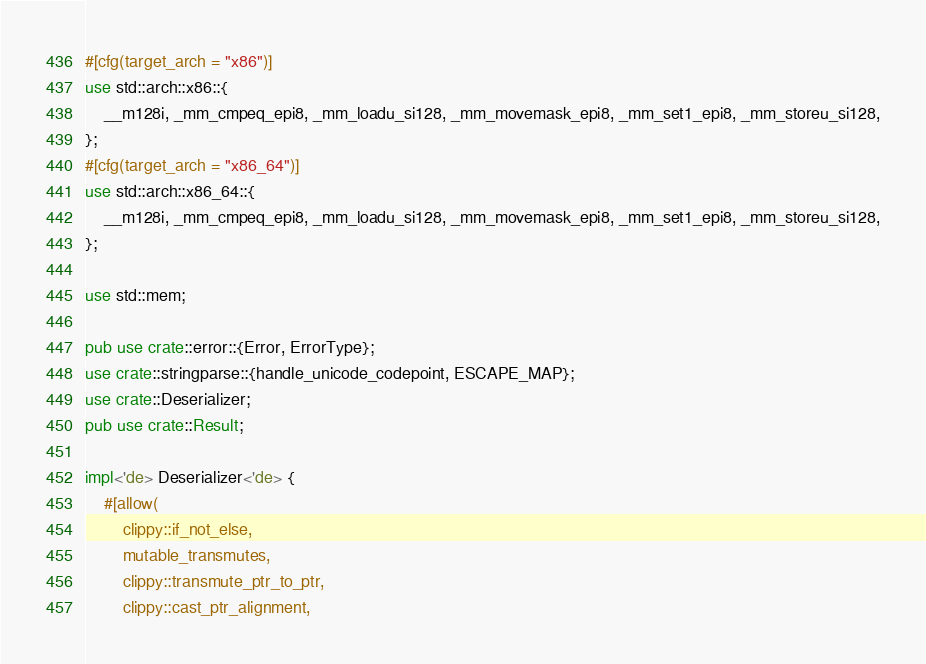<code> <loc_0><loc_0><loc_500><loc_500><_Rust_>#[cfg(target_arch = "x86")]
use std::arch::x86::{
    __m128i, _mm_cmpeq_epi8, _mm_loadu_si128, _mm_movemask_epi8, _mm_set1_epi8, _mm_storeu_si128,
};
#[cfg(target_arch = "x86_64")]
use std::arch::x86_64::{
    __m128i, _mm_cmpeq_epi8, _mm_loadu_si128, _mm_movemask_epi8, _mm_set1_epi8, _mm_storeu_si128,
};

use std::mem;

pub use crate::error::{Error, ErrorType};
use crate::stringparse::{handle_unicode_codepoint, ESCAPE_MAP};
use crate::Deserializer;
pub use crate::Result;

impl<'de> Deserializer<'de> {
    #[allow(
        clippy::if_not_else,
        mutable_transmutes,
        clippy::transmute_ptr_to_ptr,
        clippy::cast_ptr_alignment,</code> 